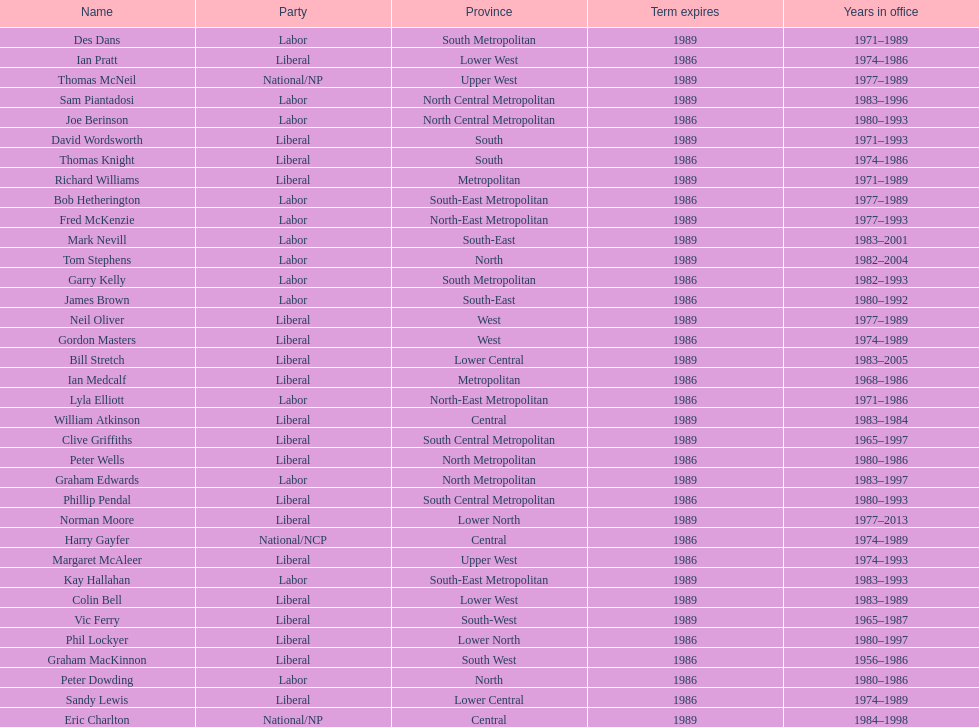Which party has the most membership? Liberal. 